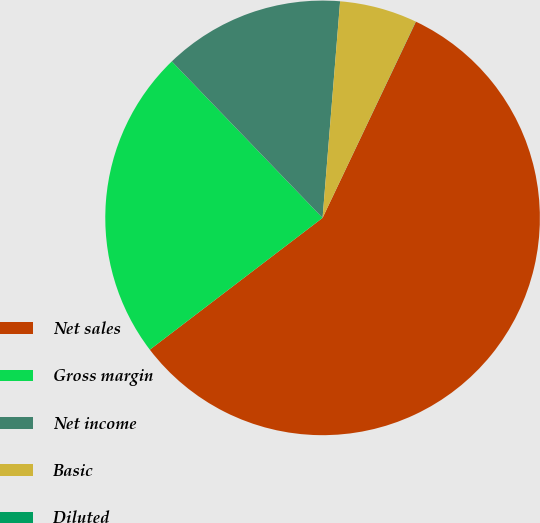<chart> <loc_0><loc_0><loc_500><loc_500><pie_chart><fcel>Net sales<fcel>Gross margin<fcel>Net income<fcel>Basic<fcel>Diluted<nl><fcel>57.56%<fcel>23.17%<fcel>13.49%<fcel>5.77%<fcel>0.01%<nl></chart> 